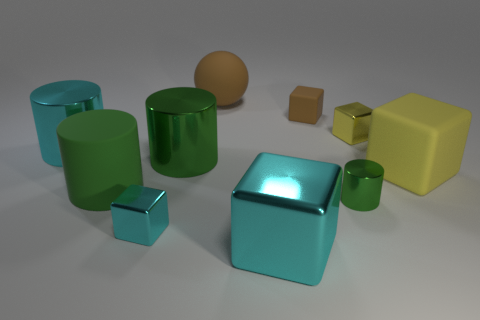What materials do the objects in the image appear to be made of? The objects in the image seem to be made from various materials that offer different textures and reflectivity. For instance, the green and blue objects have a glossy finish suggesting a polished, perhaps metallic or plastic material. The sphere and the cube on the right-hand side seem to have a matte finish, which might suggest a clay or rubber composition. 